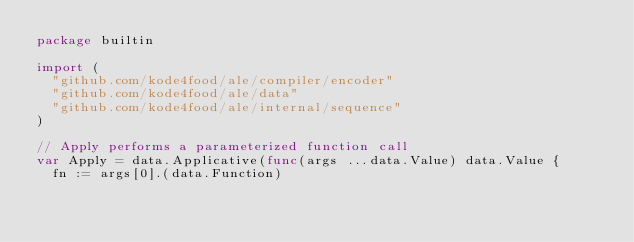<code> <loc_0><loc_0><loc_500><loc_500><_Go_>package builtin

import (
	"github.com/kode4food/ale/compiler/encoder"
	"github.com/kode4food/ale/data"
	"github.com/kode4food/ale/internal/sequence"
)

// Apply performs a parameterized function call
var Apply = data.Applicative(func(args ...data.Value) data.Value {
	fn := args[0].(data.Function)</code> 